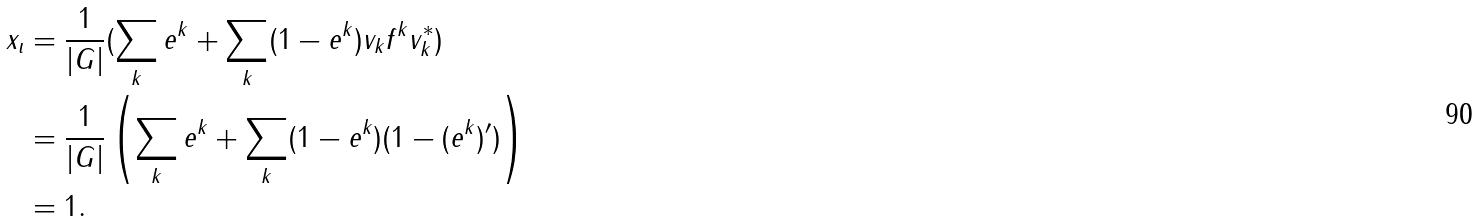Convert formula to latex. <formula><loc_0><loc_0><loc_500><loc_500>x _ { \iota } & = \frac { 1 } { | G | } ( \sum _ { k } e ^ { k } + \sum _ { k } ( 1 - e ^ { k } ) v _ { k } f ^ { k } v _ { k } ^ { * } ) \\ & = \frac { 1 } { | G | } \left ( \sum _ { k } e ^ { k } + \sum _ { k } ( 1 - e ^ { k } ) ( 1 - ( e ^ { k } ) ^ { \prime } ) \right ) \\ & = 1 .</formula> 